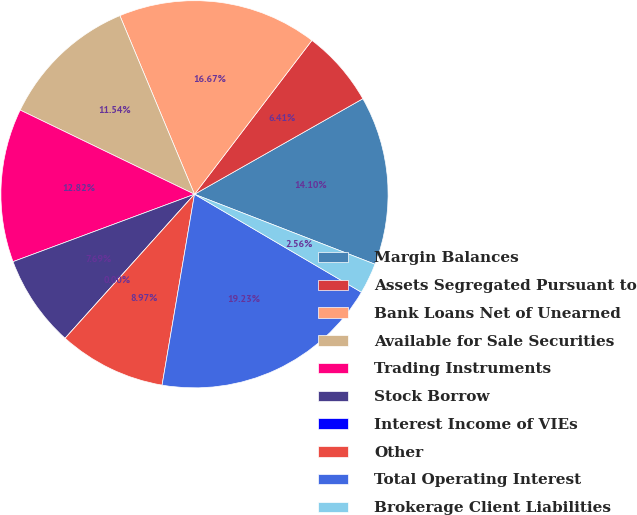<chart> <loc_0><loc_0><loc_500><loc_500><pie_chart><fcel>Margin Balances<fcel>Assets Segregated Pursuant to<fcel>Bank Loans Net of Unearned<fcel>Available for Sale Securities<fcel>Trading Instruments<fcel>Stock Borrow<fcel>Interest Income of VIEs<fcel>Other<fcel>Total Operating Interest<fcel>Brokerage Client Liabilities<nl><fcel>14.1%<fcel>6.41%<fcel>16.67%<fcel>11.54%<fcel>12.82%<fcel>7.69%<fcel>0.0%<fcel>8.97%<fcel>19.23%<fcel>2.56%<nl></chart> 